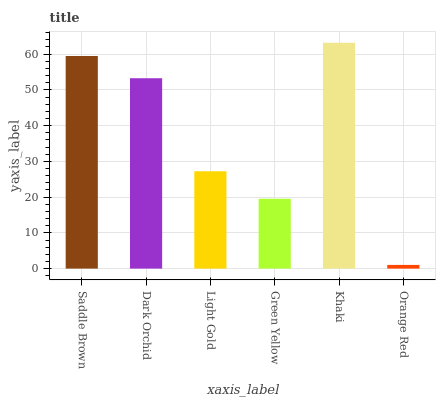Is Dark Orchid the minimum?
Answer yes or no. No. Is Dark Orchid the maximum?
Answer yes or no. No. Is Saddle Brown greater than Dark Orchid?
Answer yes or no. Yes. Is Dark Orchid less than Saddle Brown?
Answer yes or no. Yes. Is Dark Orchid greater than Saddle Brown?
Answer yes or no. No. Is Saddle Brown less than Dark Orchid?
Answer yes or no. No. Is Dark Orchid the high median?
Answer yes or no. Yes. Is Light Gold the low median?
Answer yes or no. Yes. Is Orange Red the high median?
Answer yes or no. No. Is Orange Red the low median?
Answer yes or no. No. 